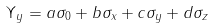Convert formula to latex. <formula><loc_0><loc_0><loc_500><loc_500>\Upsilon _ { y } = a \sigma _ { 0 } + b \sigma _ { x } + c \sigma _ { y } + d \sigma _ { z }</formula> 